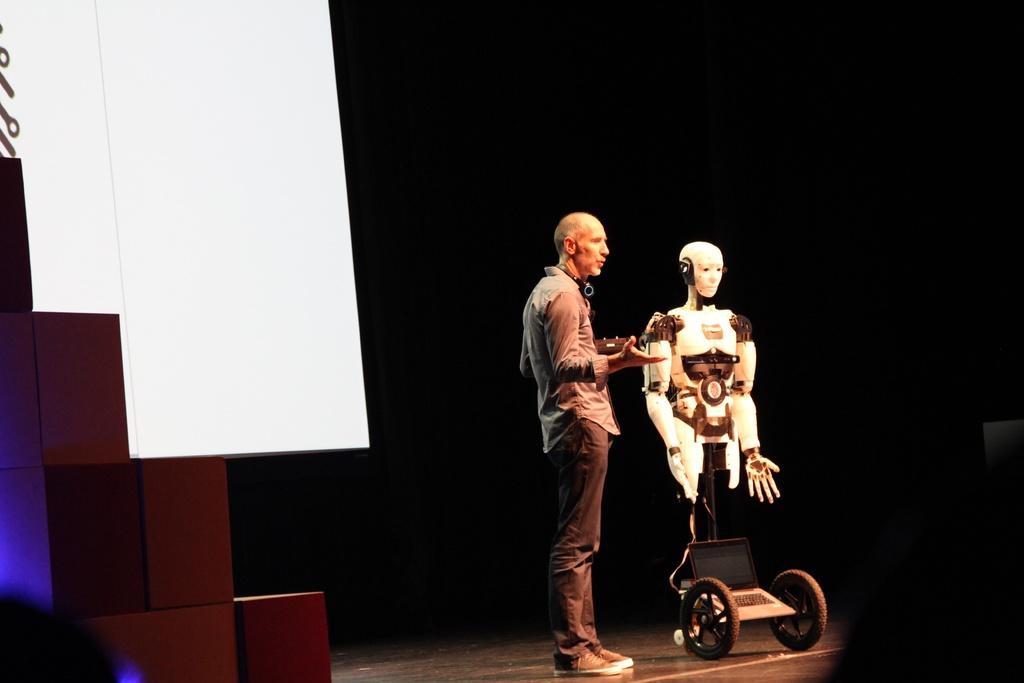Can you describe this image briefly? This image consists of a man standing on the dais and talking. Beside him, there is a robot along with the wheels. To the left, there are cables placed on one another. In the background, there are white blocks. 